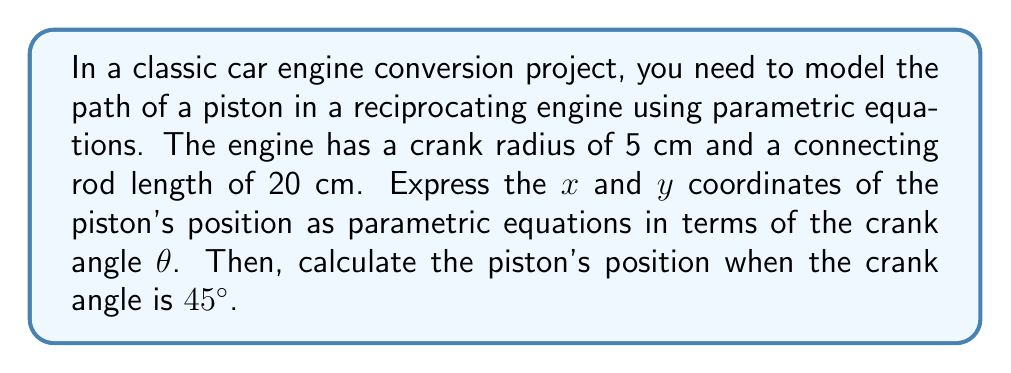Can you solve this math problem? To model the path of a piston in a reciprocating engine, we'll use parametric equations based on the crank-slider mechanism.

Let's define our variables:
- $r$ = crank radius = 5 cm
- $l$ = connecting rod length = 20 cm
- $\theta$ = crank angle (parameter)

1. Derive the parametric equations:

The x-coordinate of the piston position is given by:
$$x = r \cos\theta + \sqrt{l^2 - r^2\sin^2\theta}$$

The y-coordinate is constant (usually taken as 0) since the piston moves only horizontally:
$$y = 0$$

2. Substitute the given values:
$$x = 5 \cos\theta + \sqrt{20^2 - 5^2\sin^2\theta}$$
$$y = 0$$

3. Calculate the piston position when $\theta = 45°$:

First, convert 45° to radians: $45° = \frac{\pi}{4}$ radians

Now substitute $\theta = \frac{\pi}{4}$ into the x-equation:

$$\begin{align*}
x &= 5 \cos(\frac{\pi}{4}) + \sqrt{20^2 - 5^2\sin^2(\frac{\pi}{4})} \\
&= 5 \cdot \frac{\sqrt{2}}{2} + \sqrt{400 - 25 \cdot (\frac{\sqrt{2}}{2})^2} \\
&= \frac{5\sqrt{2}}{2} + \sqrt{400 - \frac{25}{2}} \\
&= \frac{5\sqrt{2}}{2} + \sqrt{\frac{775}{2}} \\
&≈ 3.54 + 19.69 \\
&≈ 23.23 \text{ cm}
\end{align*}$$

The y-coordinate remains 0.
Answer: The parametric equations for the piston's position are:
$$x = 5 \cos\theta + \sqrt{400 - 25\sin^2\theta}$$
$$y = 0$$

When the crank angle is 45°, the piston's position is approximately (23.23 cm, 0). 